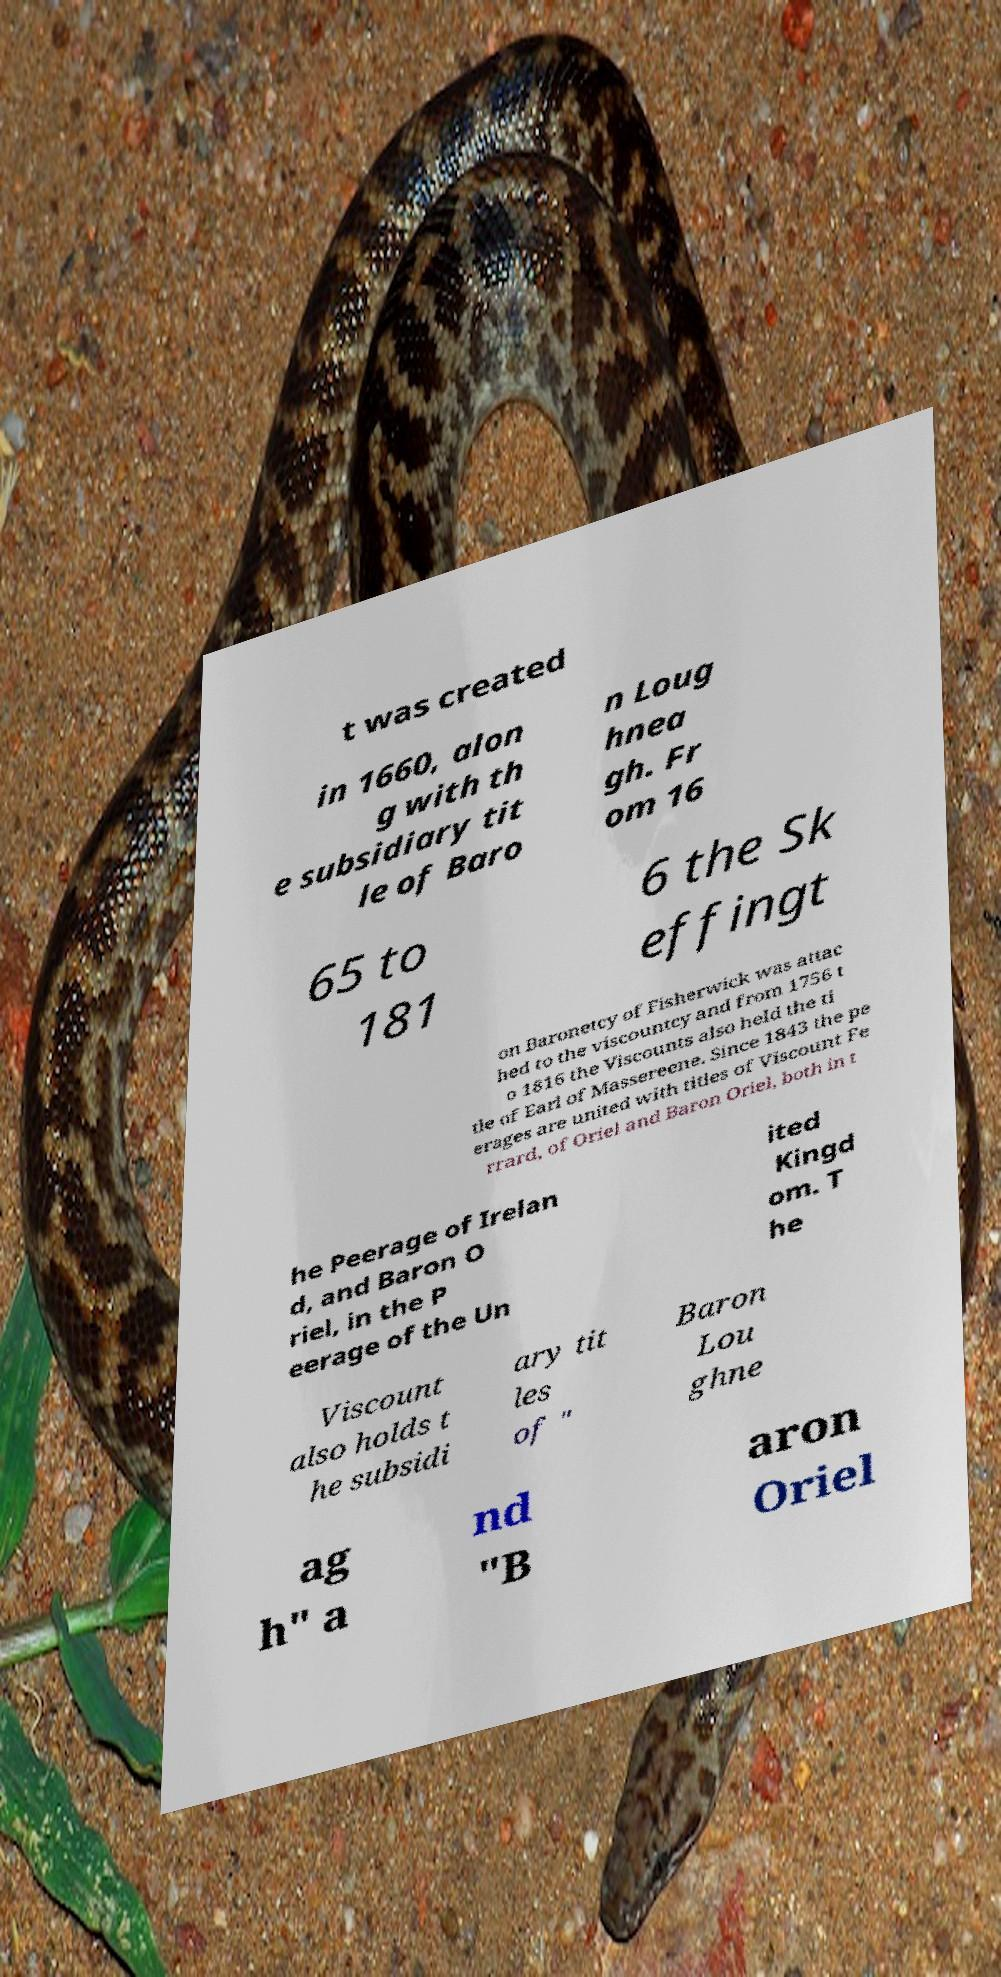Could you assist in decoding the text presented in this image and type it out clearly? t was created in 1660, alon g with th e subsidiary tit le of Baro n Loug hnea gh. Fr om 16 65 to 181 6 the Sk effingt on Baronetcy of Fisherwick was attac hed to the viscountcy and from 1756 t o 1816 the Viscounts also held the ti tle of Earl of Massereene. Since 1843 the pe erages are united with titles of Viscount Fe rrard, of Oriel and Baron Oriel, both in t he Peerage of Irelan d, and Baron O riel, in the P eerage of the Un ited Kingd om. T he Viscount also holds t he subsidi ary tit les of " Baron Lou ghne ag h" a nd "B aron Oriel 